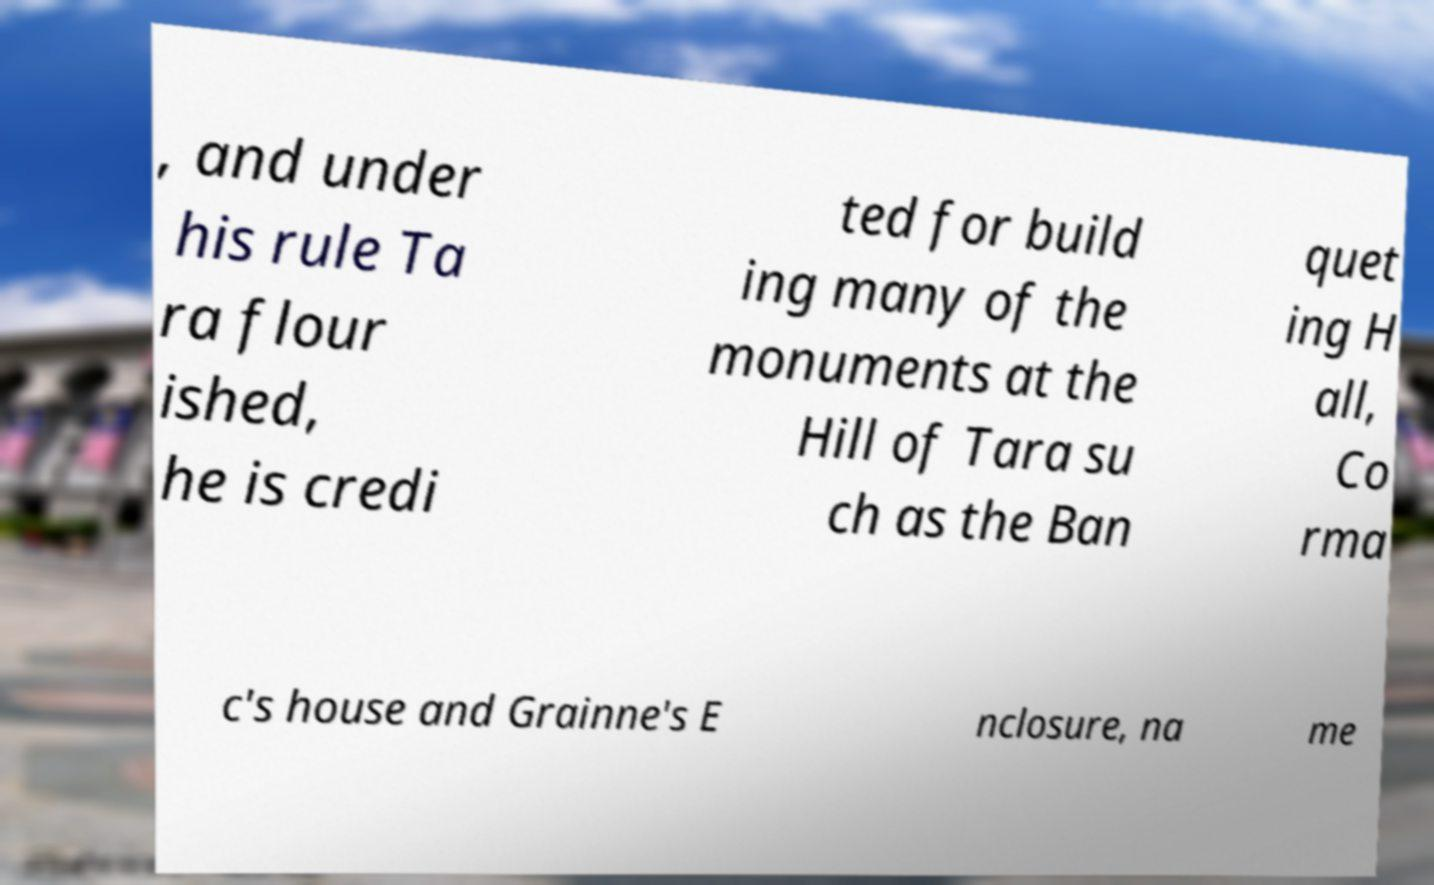For documentation purposes, I need the text within this image transcribed. Could you provide that? , and under his rule Ta ra flour ished, he is credi ted for build ing many of the monuments at the Hill of Tara su ch as the Ban quet ing H all, Co rma c's house and Grainne's E nclosure, na me 